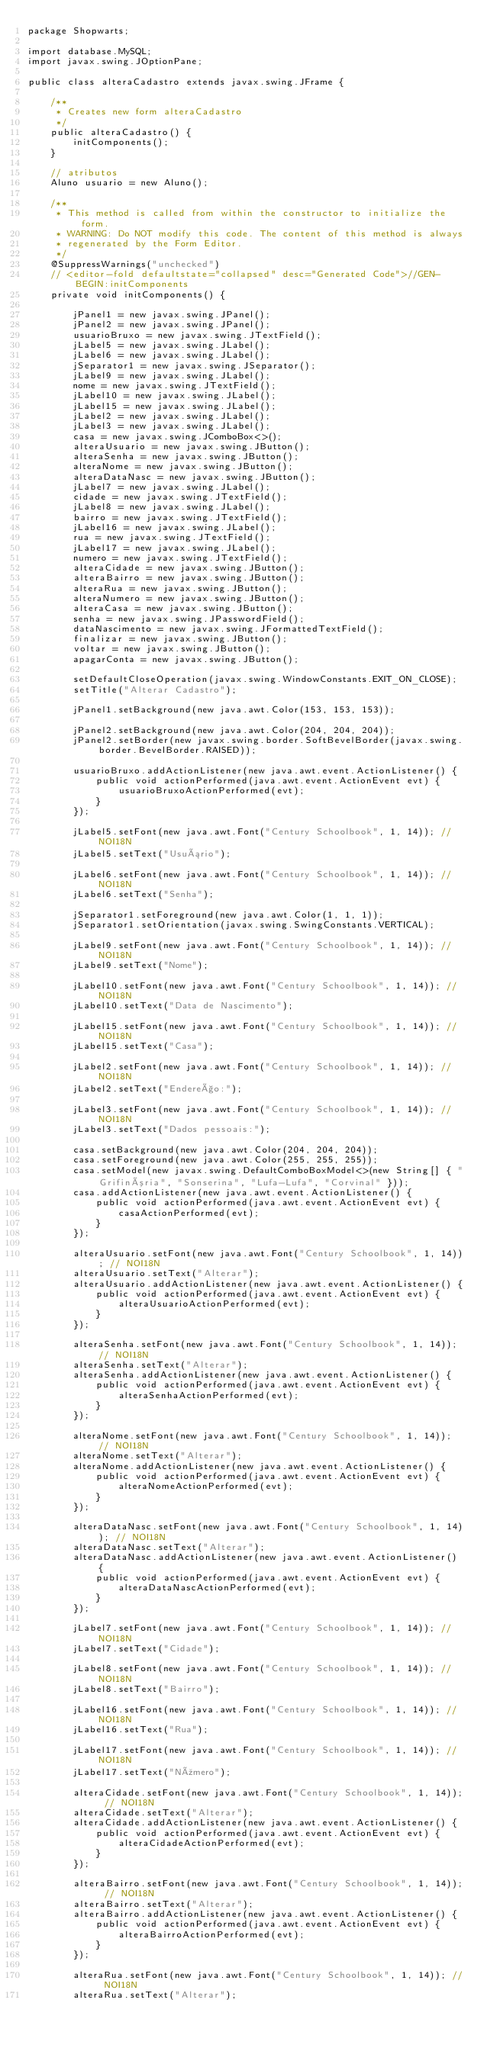Convert code to text. <code><loc_0><loc_0><loc_500><loc_500><_Java_>package Shopwarts;

import database.MySQL;
import javax.swing.JOptionPane;

public class alteraCadastro extends javax.swing.JFrame {

    /**
     * Creates new form alteraCadastro
     */
    public alteraCadastro() {
        initComponents();
    }
    
    // atributos
    Aluno usuario = new Aluno();

    /**
     * This method is called from within the constructor to initialize the form.
     * WARNING: Do NOT modify this code. The content of this method is always
     * regenerated by the Form Editor.
     */
    @SuppressWarnings("unchecked")
    // <editor-fold defaultstate="collapsed" desc="Generated Code">//GEN-BEGIN:initComponents
    private void initComponents() {

        jPanel1 = new javax.swing.JPanel();
        jPanel2 = new javax.swing.JPanel();
        usuarioBruxo = new javax.swing.JTextField();
        jLabel5 = new javax.swing.JLabel();
        jLabel6 = new javax.swing.JLabel();
        jSeparator1 = new javax.swing.JSeparator();
        jLabel9 = new javax.swing.JLabel();
        nome = new javax.swing.JTextField();
        jLabel10 = new javax.swing.JLabel();
        jLabel15 = new javax.swing.JLabel();
        jLabel2 = new javax.swing.JLabel();
        jLabel3 = new javax.swing.JLabel();
        casa = new javax.swing.JComboBox<>();
        alteraUsuario = new javax.swing.JButton();
        alteraSenha = new javax.swing.JButton();
        alteraNome = new javax.swing.JButton();
        alteraDataNasc = new javax.swing.JButton();
        jLabel7 = new javax.swing.JLabel();
        cidade = new javax.swing.JTextField();
        jLabel8 = new javax.swing.JLabel();
        bairro = new javax.swing.JTextField();
        jLabel16 = new javax.swing.JLabel();
        rua = new javax.swing.JTextField();
        jLabel17 = new javax.swing.JLabel();
        numero = new javax.swing.JTextField();
        alteraCidade = new javax.swing.JButton();
        alteraBairro = new javax.swing.JButton();
        alteraRua = new javax.swing.JButton();
        alteraNumero = new javax.swing.JButton();
        alteraCasa = new javax.swing.JButton();
        senha = new javax.swing.JPasswordField();
        dataNascimento = new javax.swing.JFormattedTextField();
        finalizar = new javax.swing.JButton();
        voltar = new javax.swing.JButton();
        apagarConta = new javax.swing.JButton();

        setDefaultCloseOperation(javax.swing.WindowConstants.EXIT_ON_CLOSE);
        setTitle("Alterar Cadastro");

        jPanel1.setBackground(new java.awt.Color(153, 153, 153));

        jPanel2.setBackground(new java.awt.Color(204, 204, 204));
        jPanel2.setBorder(new javax.swing.border.SoftBevelBorder(javax.swing.border.BevelBorder.RAISED));

        usuarioBruxo.addActionListener(new java.awt.event.ActionListener() {
            public void actionPerformed(java.awt.event.ActionEvent evt) {
                usuarioBruxoActionPerformed(evt);
            }
        });

        jLabel5.setFont(new java.awt.Font("Century Schoolbook", 1, 14)); // NOI18N
        jLabel5.setText("Usuário");

        jLabel6.setFont(new java.awt.Font("Century Schoolbook", 1, 14)); // NOI18N
        jLabel6.setText("Senha");

        jSeparator1.setForeground(new java.awt.Color(1, 1, 1));
        jSeparator1.setOrientation(javax.swing.SwingConstants.VERTICAL);

        jLabel9.setFont(new java.awt.Font("Century Schoolbook", 1, 14)); // NOI18N
        jLabel9.setText("Nome");

        jLabel10.setFont(new java.awt.Font("Century Schoolbook", 1, 14)); // NOI18N
        jLabel10.setText("Data de Nascimento");

        jLabel15.setFont(new java.awt.Font("Century Schoolbook", 1, 14)); // NOI18N
        jLabel15.setText("Casa");

        jLabel2.setFont(new java.awt.Font("Century Schoolbook", 1, 14)); // NOI18N
        jLabel2.setText("Endereço:");

        jLabel3.setFont(new java.awt.Font("Century Schoolbook", 1, 14)); // NOI18N
        jLabel3.setText("Dados pessoais:");

        casa.setBackground(new java.awt.Color(204, 204, 204));
        casa.setForeground(new java.awt.Color(255, 255, 255));
        casa.setModel(new javax.swing.DefaultComboBoxModel<>(new String[] { "Grifinória", "Sonserina", "Lufa-Lufa", "Corvinal" }));
        casa.addActionListener(new java.awt.event.ActionListener() {
            public void actionPerformed(java.awt.event.ActionEvent evt) {
                casaActionPerformed(evt);
            }
        });

        alteraUsuario.setFont(new java.awt.Font("Century Schoolbook", 1, 14)); // NOI18N
        alteraUsuario.setText("Alterar");
        alteraUsuario.addActionListener(new java.awt.event.ActionListener() {
            public void actionPerformed(java.awt.event.ActionEvent evt) {
                alteraUsuarioActionPerformed(evt);
            }
        });

        alteraSenha.setFont(new java.awt.Font("Century Schoolbook", 1, 14)); // NOI18N
        alteraSenha.setText("Alterar");
        alteraSenha.addActionListener(new java.awt.event.ActionListener() {
            public void actionPerformed(java.awt.event.ActionEvent evt) {
                alteraSenhaActionPerformed(evt);
            }
        });

        alteraNome.setFont(new java.awt.Font("Century Schoolbook", 1, 14)); // NOI18N
        alteraNome.setText("Alterar");
        alteraNome.addActionListener(new java.awt.event.ActionListener() {
            public void actionPerformed(java.awt.event.ActionEvent evt) {
                alteraNomeActionPerformed(evt);
            }
        });

        alteraDataNasc.setFont(new java.awt.Font("Century Schoolbook", 1, 14)); // NOI18N
        alteraDataNasc.setText("Alterar");
        alteraDataNasc.addActionListener(new java.awt.event.ActionListener() {
            public void actionPerformed(java.awt.event.ActionEvent evt) {
                alteraDataNascActionPerformed(evt);
            }
        });

        jLabel7.setFont(new java.awt.Font("Century Schoolbook", 1, 14)); // NOI18N
        jLabel7.setText("Cidade");

        jLabel8.setFont(new java.awt.Font("Century Schoolbook", 1, 14)); // NOI18N
        jLabel8.setText("Bairro");

        jLabel16.setFont(new java.awt.Font("Century Schoolbook", 1, 14)); // NOI18N
        jLabel16.setText("Rua");

        jLabel17.setFont(new java.awt.Font("Century Schoolbook", 1, 14)); // NOI18N
        jLabel17.setText("Número");

        alteraCidade.setFont(new java.awt.Font("Century Schoolbook", 1, 14)); // NOI18N
        alteraCidade.setText("Alterar");
        alteraCidade.addActionListener(new java.awt.event.ActionListener() {
            public void actionPerformed(java.awt.event.ActionEvent evt) {
                alteraCidadeActionPerformed(evt);
            }
        });

        alteraBairro.setFont(new java.awt.Font("Century Schoolbook", 1, 14)); // NOI18N
        alteraBairro.setText("Alterar");
        alteraBairro.addActionListener(new java.awt.event.ActionListener() {
            public void actionPerformed(java.awt.event.ActionEvent evt) {
                alteraBairroActionPerformed(evt);
            }
        });

        alteraRua.setFont(new java.awt.Font("Century Schoolbook", 1, 14)); // NOI18N
        alteraRua.setText("Alterar");</code> 